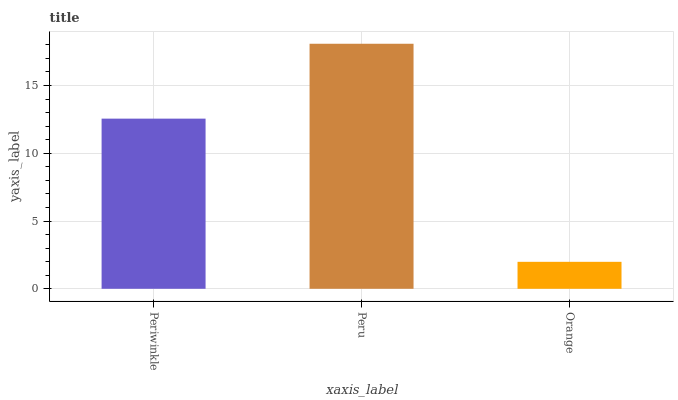Is Peru the minimum?
Answer yes or no. No. Is Orange the maximum?
Answer yes or no. No. Is Peru greater than Orange?
Answer yes or no. Yes. Is Orange less than Peru?
Answer yes or no. Yes. Is Orange greater than Peru?
Answer yes or no. No. Is Peru less than Orange?
Answer yes or no. No. Is Periwinkle the high median?
Answer yes or no. Yes. Is Periwinkle the low median?
Answer yes or no. Yes. Is Orange the high median?
Answer yes or no. No. Is Peru the low median?
Answer yes or no. No. 